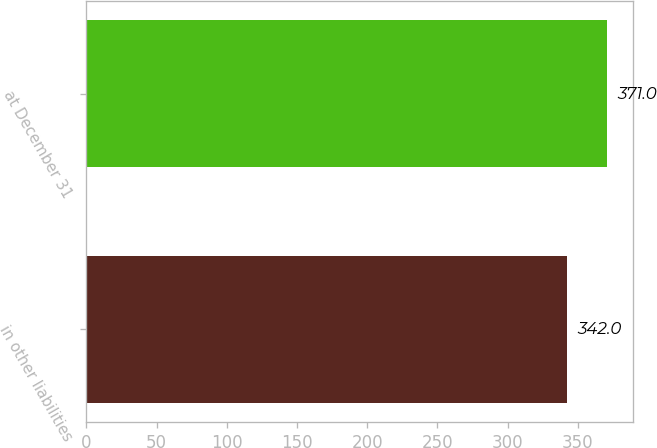Convert chart. <chart><loc_0><loc_0><loc_500><loc_500><bar_chart><fcel>in other liabilities<fcel>at December 31<nl><fcel>342<fcel>371<nl></chart> 